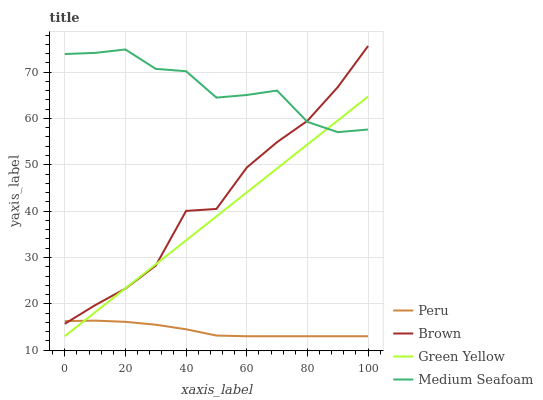Does Peru have the minimum area under the curve?
Answer yes or no. Yes. Does Medium Seafoam have the maximum area under the curve?
Answer yes or no. Yes. Does Green Yellow have the minimum area under the curve?
Answer yes or no. No. Does Green Yellow have the maximum area under the curve?
Answer yes or no. No. Is Green Yellow the smoothest?
Answer yes or no. Yes. Is Brown the roughest?
Answer yes or no. Yes. Is Medium Seafoam the smoothest?
Answer yes or no. No. Is Medium Seafoam the roughest?
Answer yes or no. No. Does Green Yellow have the lowest value?
Answer yes or no. Yes. Does Medium Seafoam have the lowest value?
Answer yes or no. No. Does Brown have the highest value?
Answer yes or no. Yes. Does Green Yellow have the highest value?
Answer yes or no. No. Is Peru less than Medium Seafoam?
Answer yes or no. Yes. Is Medium Seafoam greater than Peru?
Answer yes or no. Yes. Does Brown intersect Peru?
Answer yes or no. Yes. Is Brown less than Peru?
Answer yes or no. No. Is Brown greater than Peru?
Answer yes or no. No. Does Peru intersect Medium Seafoam?
Answer yes or no. No. 